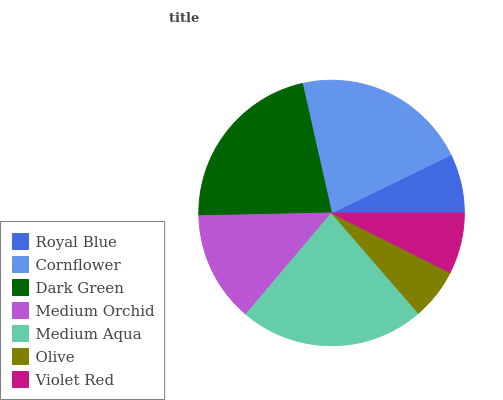Is Olive the minimum?
Answer yes or no. Yes. Is Medium Aqua the maximum?
Answer yes or no. Yes. Is Cornflower the minimum?
Answer yes or no. No. Is Cornflower the maximum?
Answer yes or no. No. Is Cornflower greater than Royal Blue?
Answer yes or no. Yes. Is Royal Blue less than Cornflower?
Answer yes or no. Yes. Is Royal Blue greater than Cornflower?
Answer yes or no. No. Is Cornflower less than Royal Blue?
Answer yes or no. No. Is Medium Orchid the high median?
Answer yes or no. Yes. Is Medium Orchid the low median?
Answer yes or no. Yes. Is Violet Red the high median?
Answer yes or no. No. Is Medium Aqua the low median?
Answer yes or no. No. 